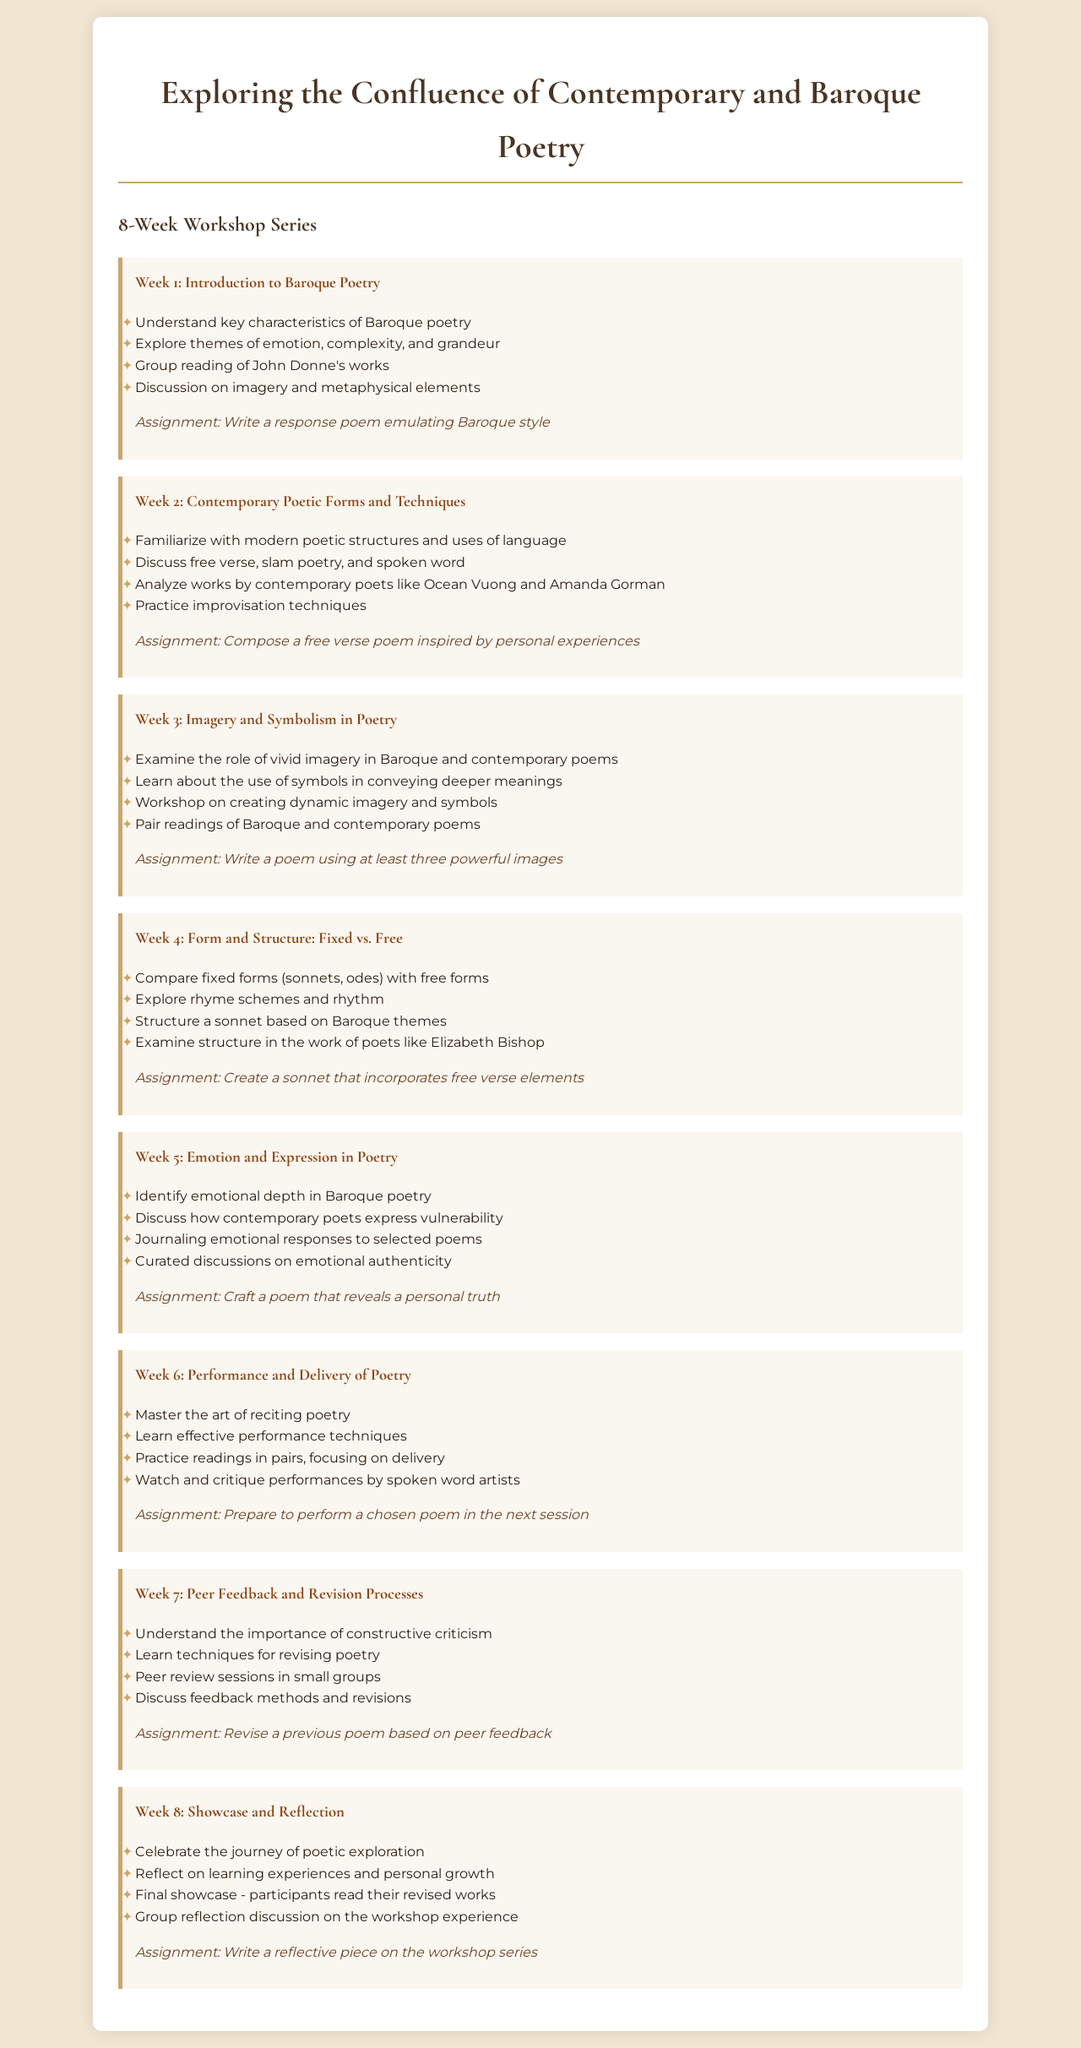What is the title of the workshop series? The title of the workshop series is mentioned in the document's header.
Answer: Exploring the Confluence of Contemporary and Baroque Poetry How many weeks does the workshop series last? The document states that this is an 8-week workshop series.
Answer: 8 Which poet's works are discussed in Week 1? In Week 1, there is a group reading of the works of a specific poet known for his Baroque style.
Answer: John Donne What is the assignment for Week 5? The assignment for Week 5 involves crafting a poem that reveals a personal truth.
Answer: Craft a poem that reveals a personal truth In which week do participants learn effective performance techniques? The week in which effective performance techniques are learned is indicated clearly in the workshop schedule.
Answer: Week 6 What key theme is explored in Week 3? Week 3 focuses on a specific literary device that is crucial in both Baroque and contemporary poetry.
Answer: Imagery and Symbolism What is the primary focus of Week 7? The primary focus of Week 7 is indicated as a process crucial for developing poetry further.
Answer: Peer Feedback and Revision Processes What task is assigned in the final week? The final assignment of the workshop series is aimed at reflecting on the entire experience.
Answer: Write a reflective piece on the workshop series 